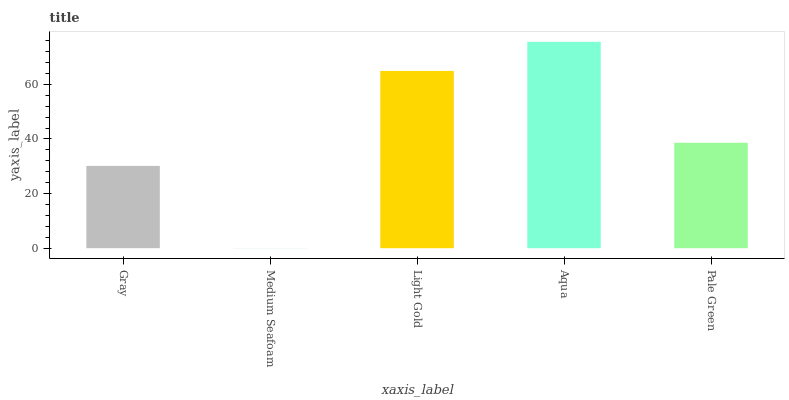Is Medium Seafoam the minimum?
Answer yes or no. Yes. Is Aqua the maximum?
Answer yes or no. Yes. Is Light Gold the minimum?
Answer yes or no. No. Is Light Gold the maximum?
Answer yes or no. No. Is Light Gold greater than Medium Seafoam?
Answer yes or no. Yes. Is Medium Seafoam less than Light Gold?
Answer yes or no. Yes. Is Medium Seafoam greater than Light Gold?
Answer yes or no. No. Is Light Gold less than Medium Seafoam?
Answer yes or no. No. Is Pale Green the high median?
Answer yes or no. Yes. Is Pale Green the low median?
Answer yes or no. Yes. Is Light Gold the high median?
Answer yes or no. No. Is Aqua the low median?
Answer yes or no. No. 